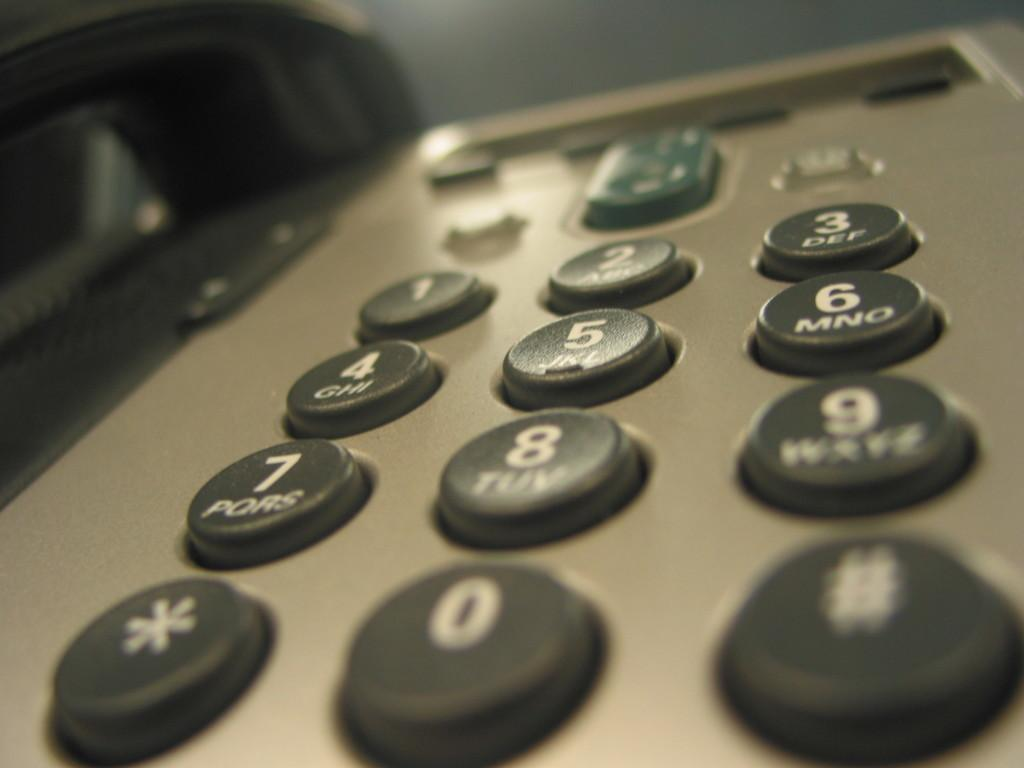<image>
Provide a brief description of the given image. A close-up view of a telephone number pad with 0 in the bottom row in the middle. 